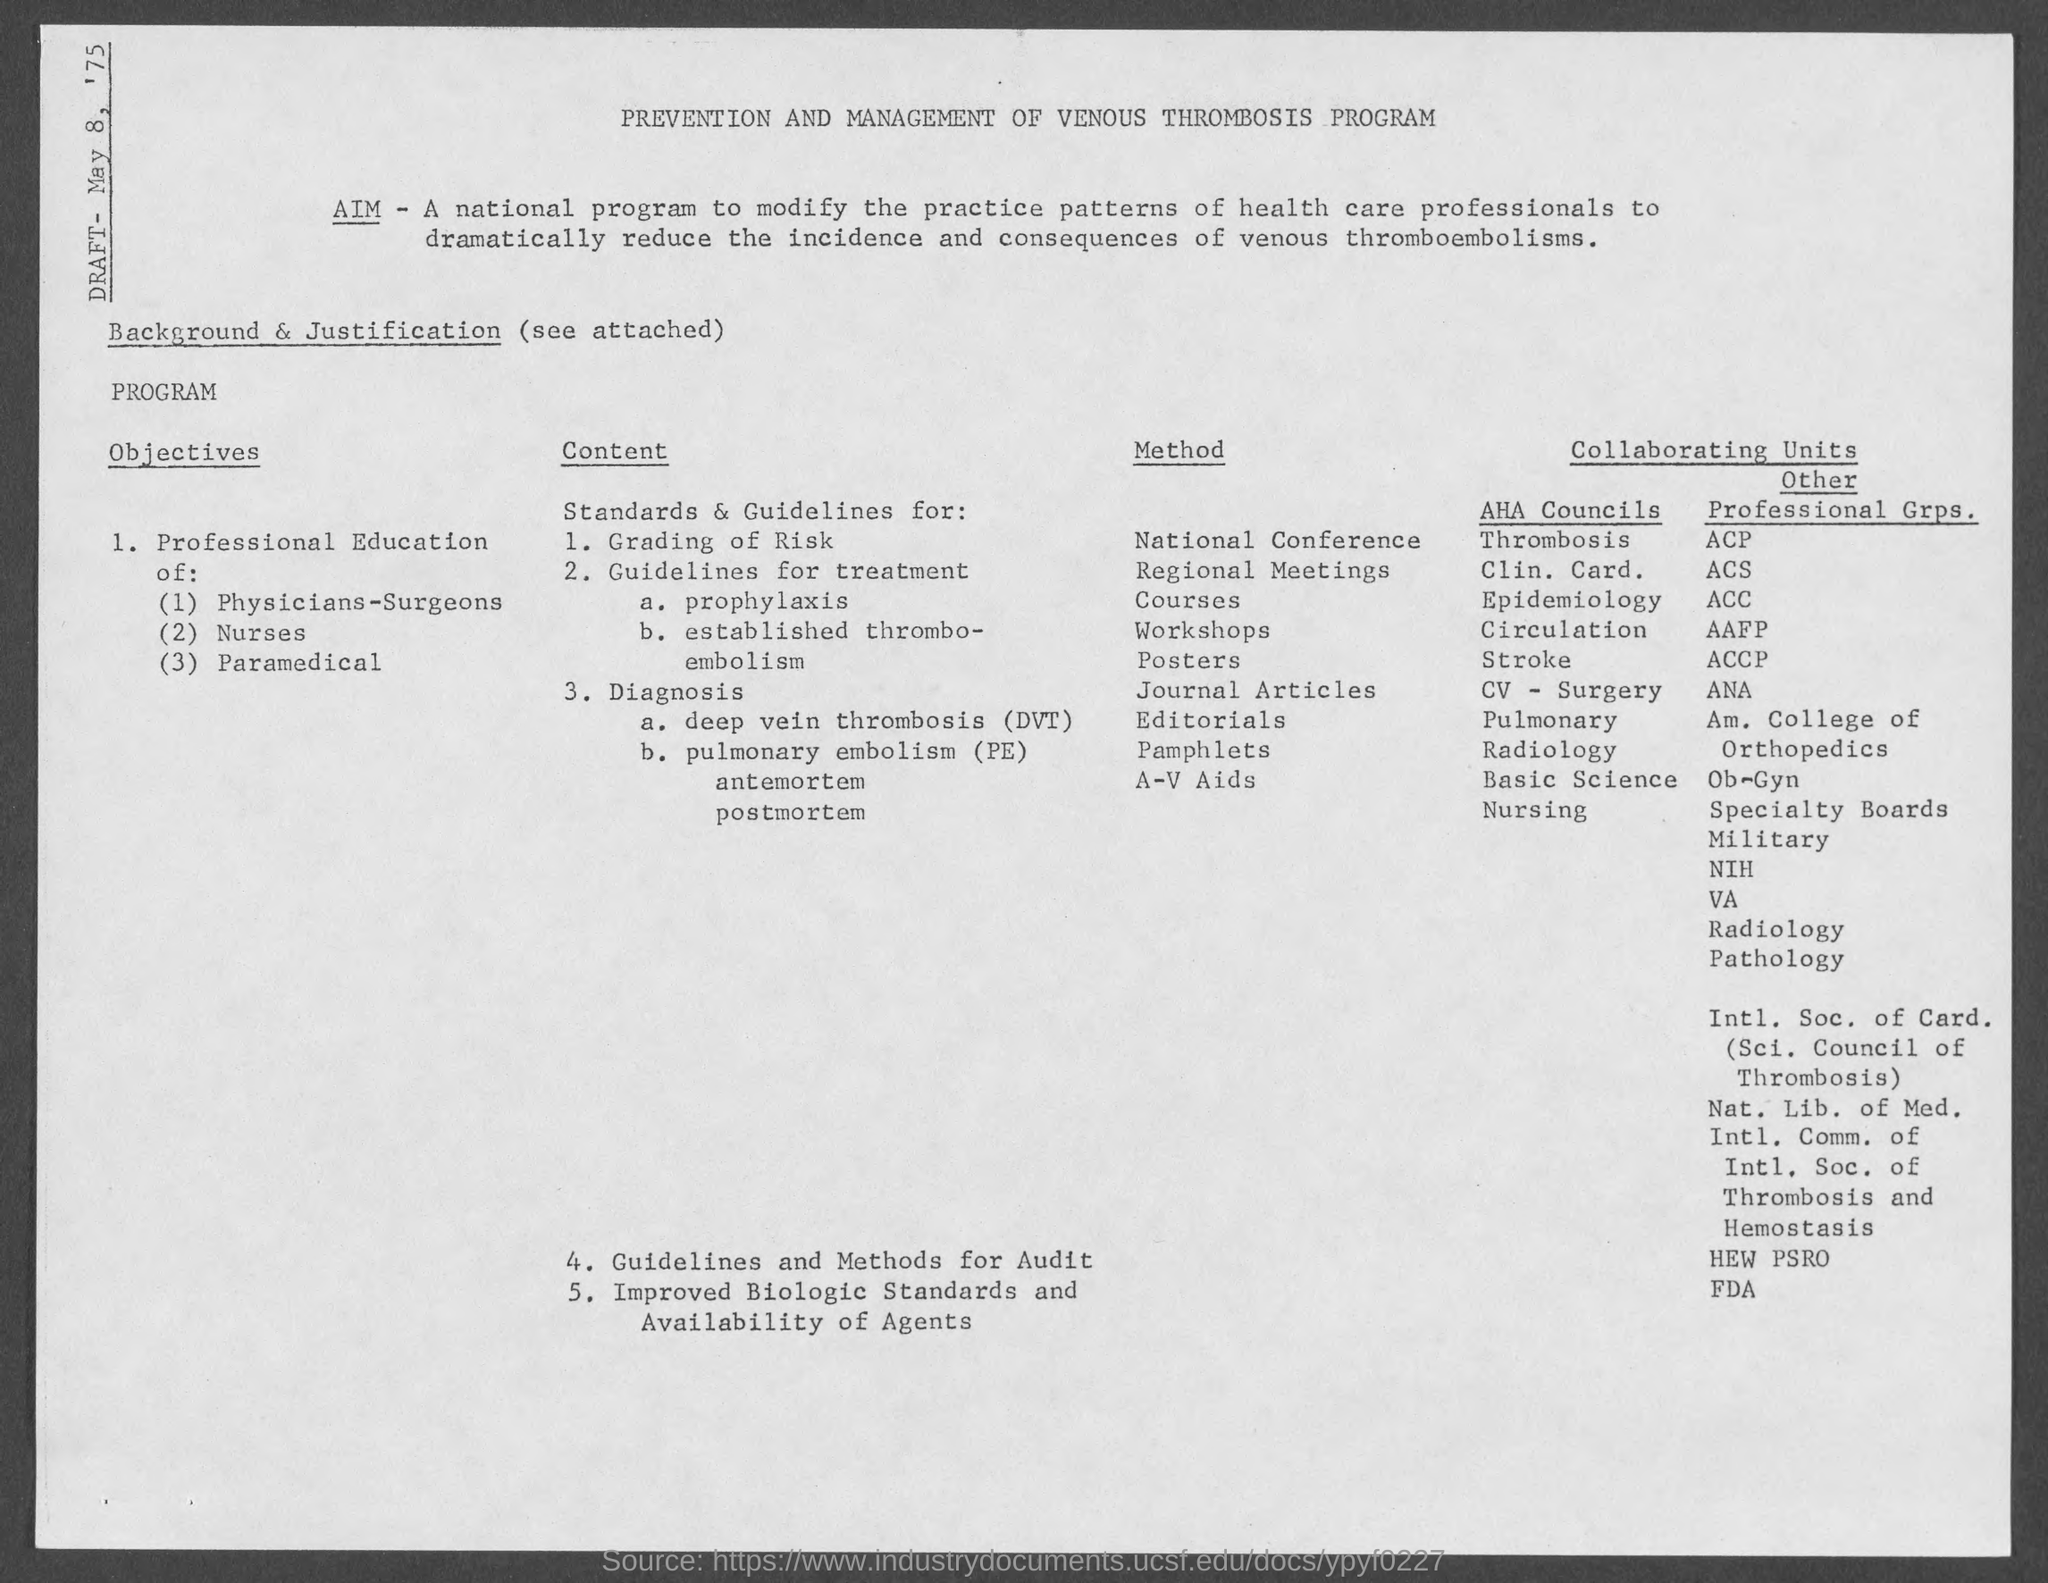Indicate a few pertinent items in this graphic. The first method used was the National Conference method. Grading of Risk is the first content. The date of the draft is May 8, 1975. The document's heading is "PREVENTION AND MANAGEMENT OF VENOUS THROMBOSIS PROGRAM. 